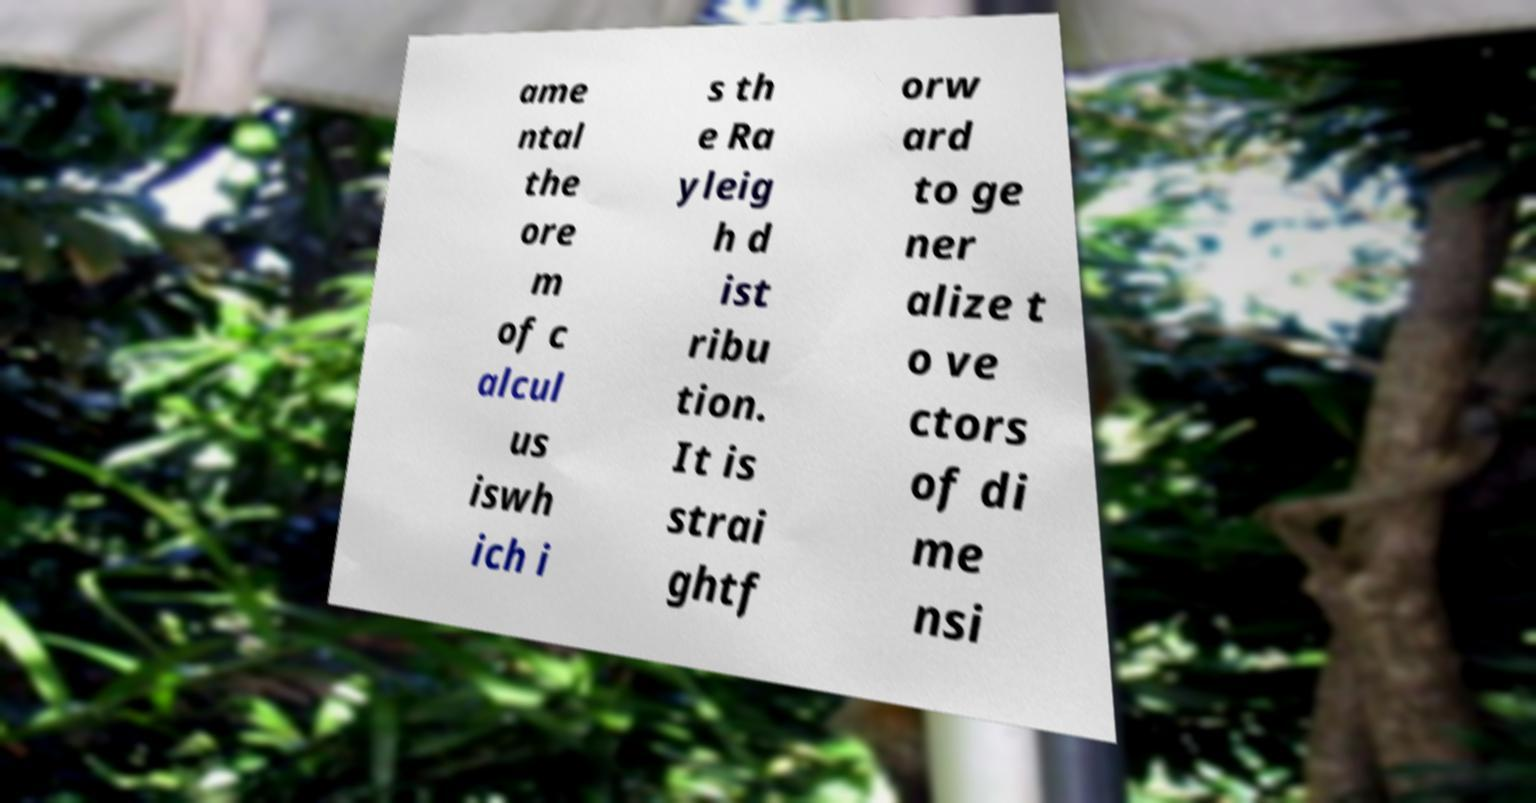Can you accurately transcribe the text from the provided image for me? ame ntal the ore m of c alcul us iswh ich i s th e Ra yleig h d ist ribu tion. It is strai ghtf orw ard to ge ner alize t o ve ctors of di me nsi 